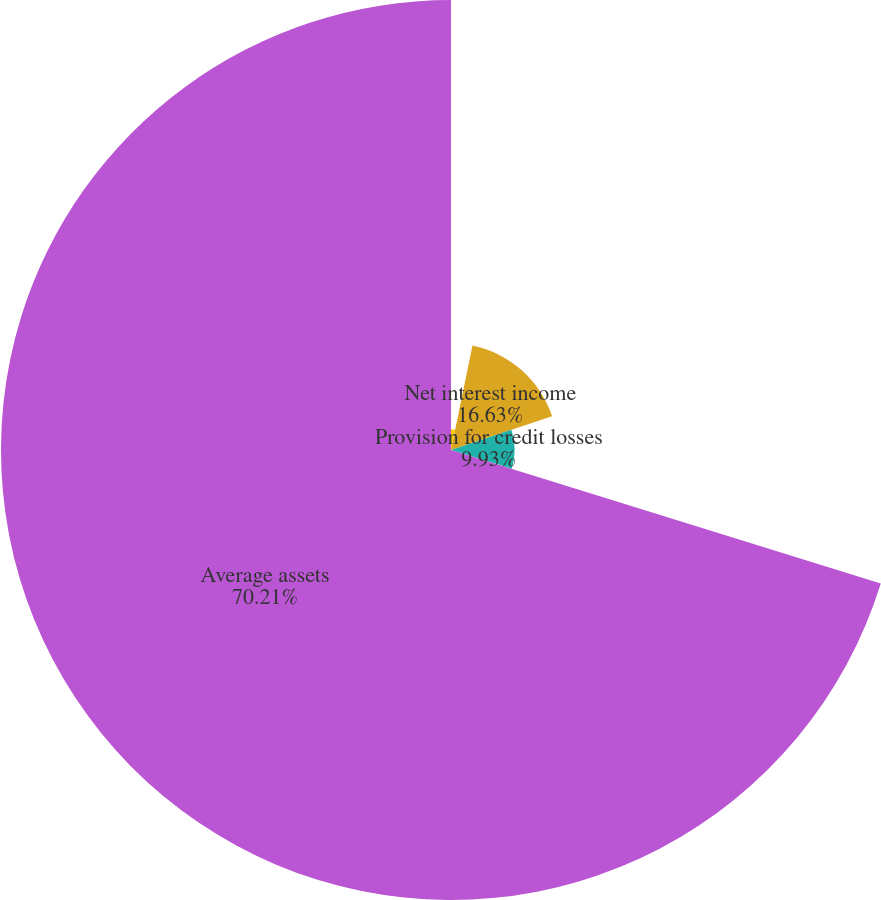<chart> <loc_0><loc_0><loc_500><loc_500><pie_chart><fcel>Noninterest revenue<fcel>Net interest income<fcel>Provision for credit losses<fcel>Average assets<nl><fcel>3.23%<fcel>16.63%<fcel>9.93%<fcel>70.21%<nl></chart> 